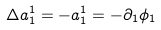<formula> <loc_0><loc_0><loc_500><loc_500>\Delta a ^ { 1 } _ { 1 } = - a ^ { 1 } _ { 1 } = - \partial _ { 1 } \phi _ { 1 }</formula> 